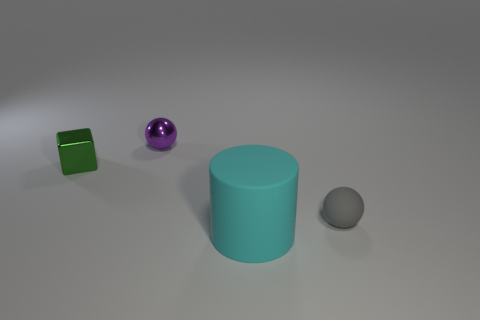Add 1 small objects. How many objects exist? 5 Subtract all cylinders. How many objects are left? 3 Subtract 1 cylinders. How many cylinders are left? 0 Subtract all red cylinders. Subtract all red cubes. How many cylinders are left? 1 Subtract all brown blocks. How many yellow cylinders are left? 0 Subtract all purple balls. Subtract all brown balls. How many objects are left? 3 Add 2 cylinders. How many cylinders are left? 3 Add 1 brown rubber cubes. How many brown rubber cubes exist? 1 Subtract 1 gray balls. How many objects are left? 3 